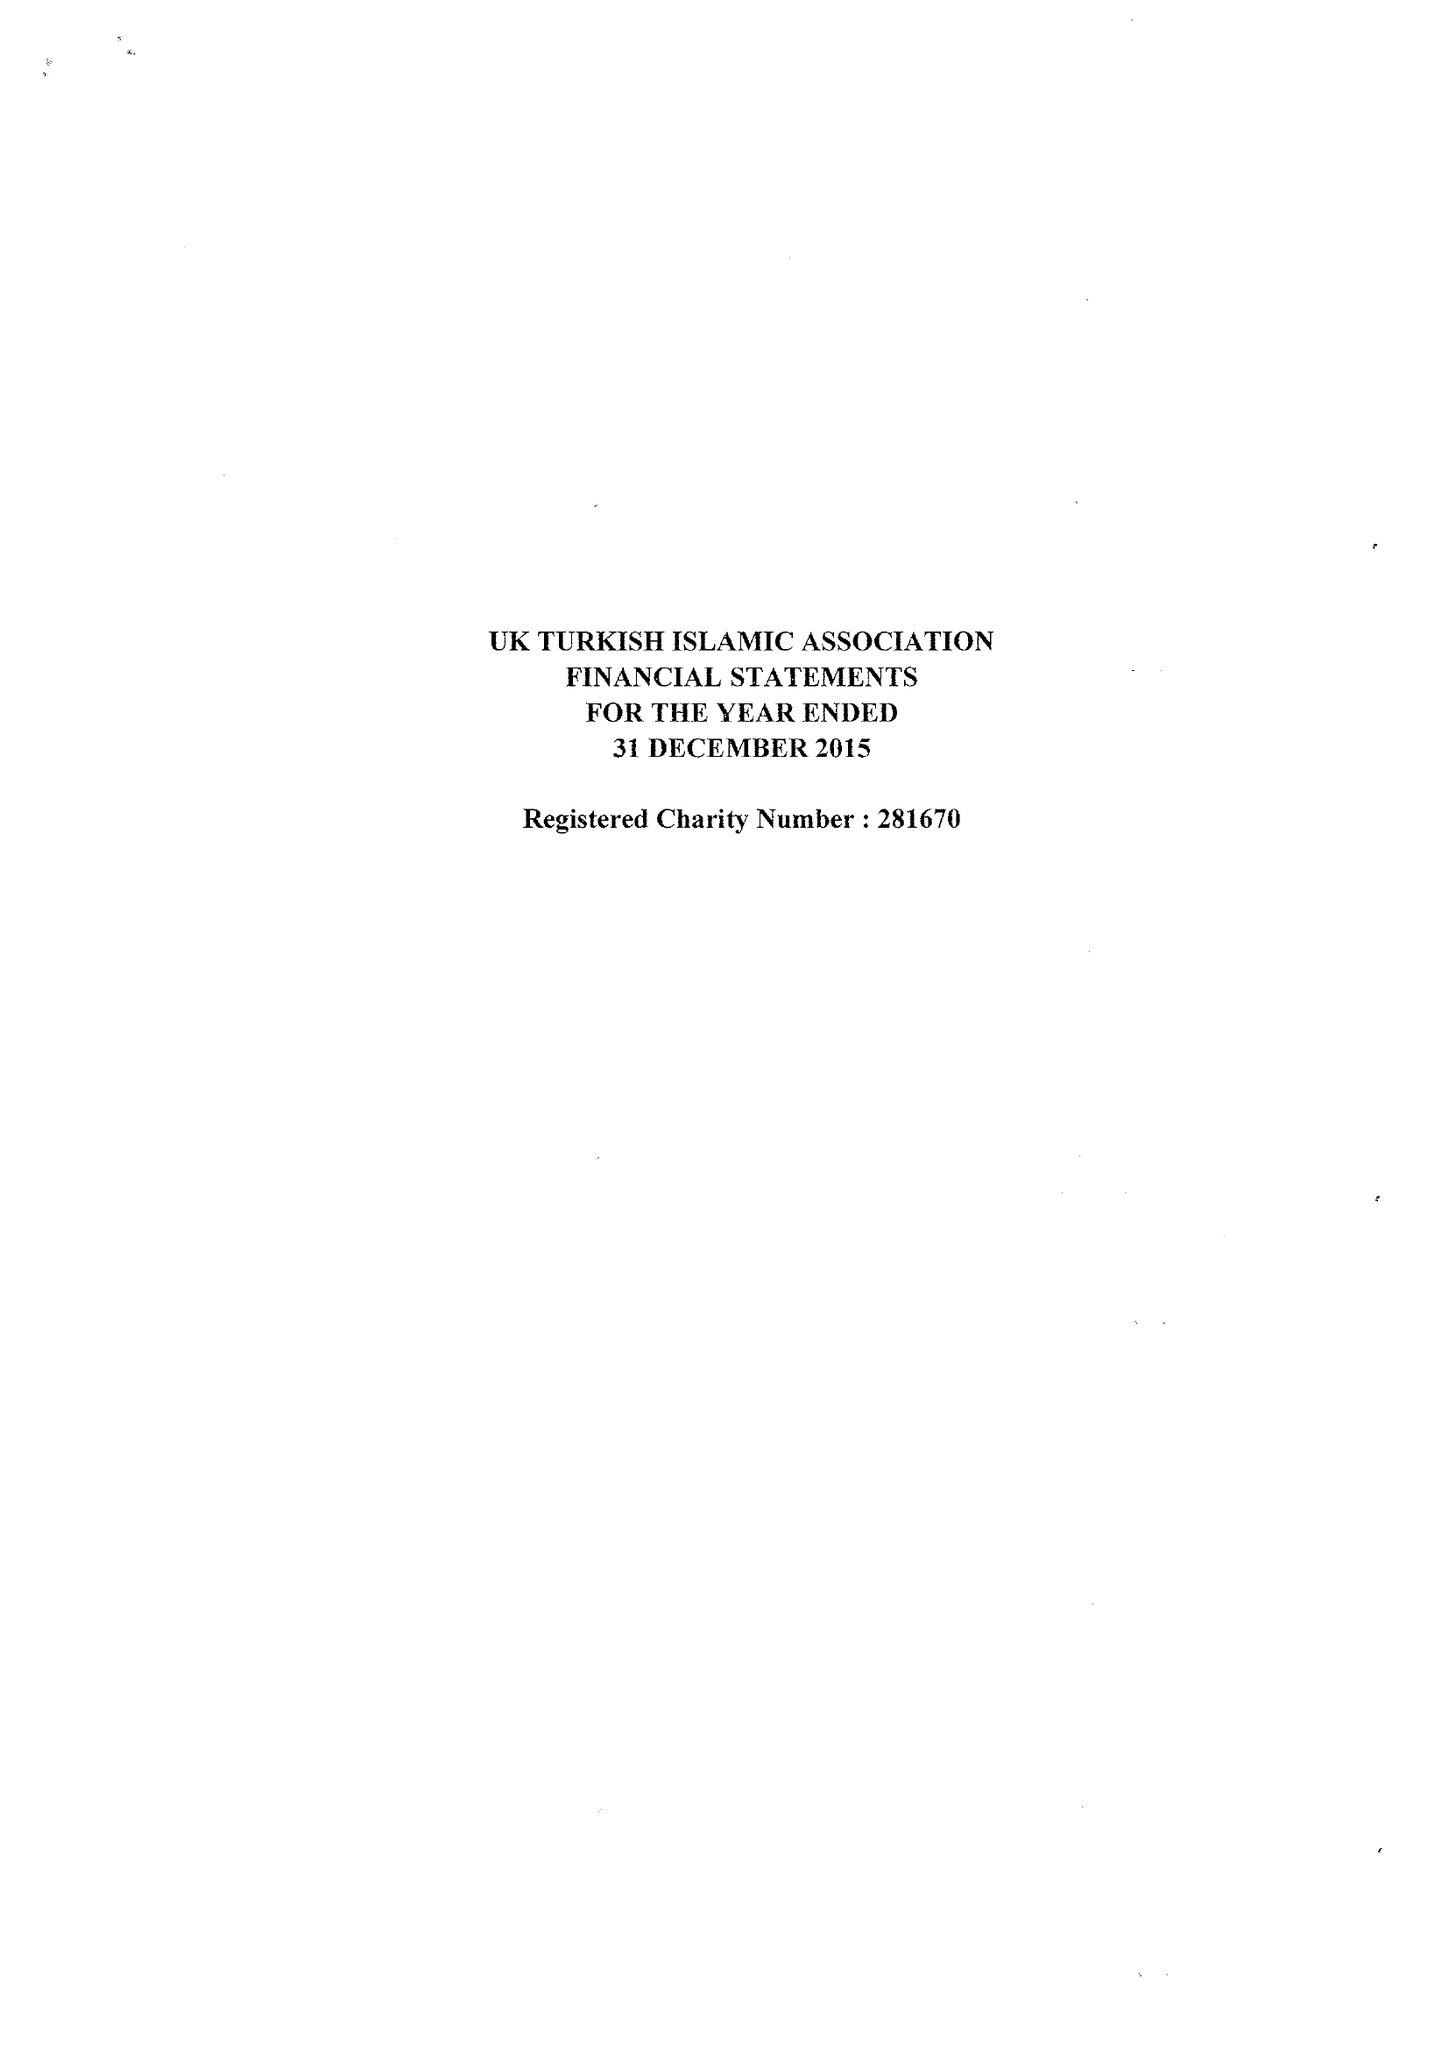What is the value for the charity_name?
Answer the question using a single word or phrase. United Kingdom Turkish Islamic Association 